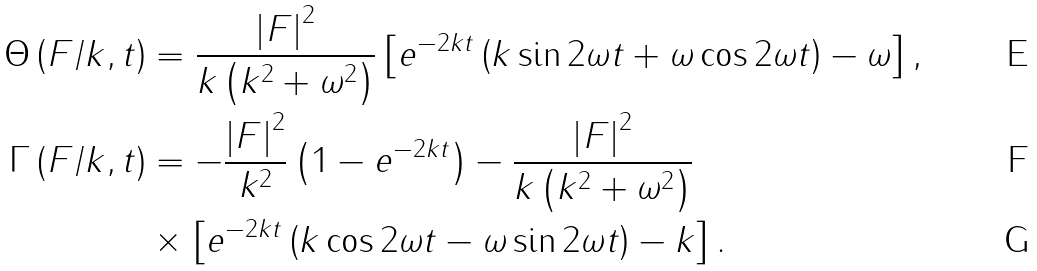<formula> <loc_0><loc_0><loc_500><loc_500>\Theta \left ( F / k , t \right ) & = \frac { \left | F \right | ^ { 2 } } { k \left ( k ^ { 2 } + \omega ^ { 2 } \right ) } \left [ e ^ { - 2 k t } \left ( k \sin 2 \omega t + \omega \cos 2 \omega t \right ) - \omega \right ] , \\ \Gamma \left ( F / k , t \right ) & = - \frac { \left | F \right | ^ { 2 } } { k ^ { 2 } } \left ( 1 - e ^ { - 2 k t } \right ) - \frac { \left | F \right | ^ { 2 } } { k \left ( k ^ { 2 } + \omega ^ { 2 } \right ) } \\ & \times \left [ e ^ { - 2 k t } \left ( k \cos 2 \omega t - \omega \sin 2 \omega t \right ) - k \right ] .</formula> 